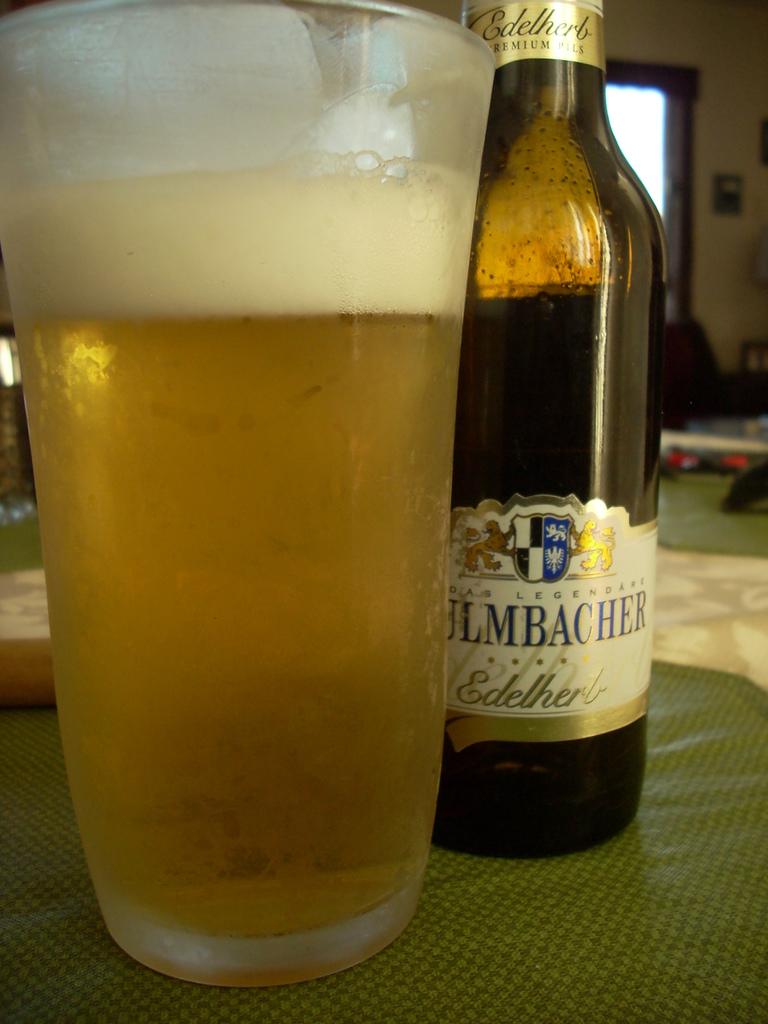Who makes this beer?
Provide a succinct answer. Ulmbacher. 